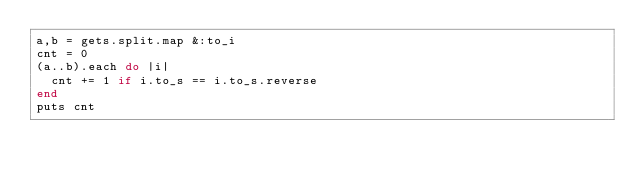<code> <loc_0><loc_0><loc_500><loc_500><_Ruby_>a,b = gets.split.map &:to_i
cnt = 0
(a..b).each do |i|
  cnt += 1 if i.to_s == i.to_s.reverse
end
puts cnt</code> 